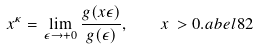<formula> <loc_0><loc_0><loc_500><loc_500>x ^ { \kappa } = \lim _ { \epsilon \to + 0 } \frac { g ( x \epsilon ) } { g ( \epsilon ) } , \quad x \, > 0 . \L a b e l { 8 2 }</formula> 